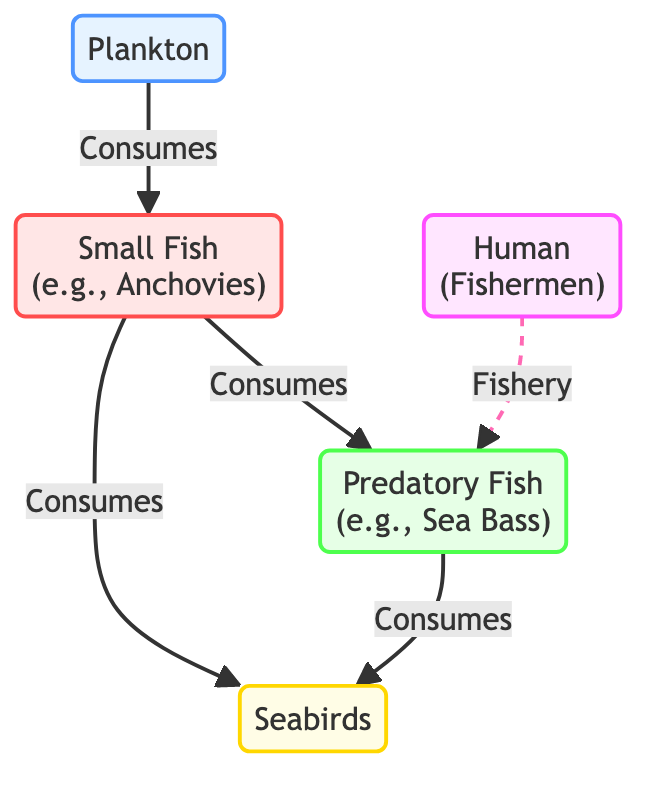What are the nodes in the diagram? The diagram includes the following nodes: Plankton, Small Fish, Predatory Fish, Human, and Seabirds.
Answer: Plankton, Small Fish, Predatory Fish, Human, Seabirds What type of fish is directly consumed by small fish? The diagram indicates that small fish consume plankton.
Answer: Plankton How many primary consumers are present in the diagram? There are two primary consumers visible in the diagram: small fish and seabirds.
Answer: 2 Who are the human participants in the food chain? The diagram shows humans represented as fishermen in the food chain.
Answer: Fishermen Which fish consumes seabirds according to the diagram? The diagram indicates that predatory fish consume seabirds.
Answer: Predatory Fish What is the relationship between plankton and small fish? Small fish consume plankton according to the flow represented in the diagram.
Answer: Consumes How many paths lead away from the small fish node? The small fish node has three paths leading away: to predatory fish and to seabirds (with one being implied through consumption).
Answer: 3 What type of arrow represents the fishery relationship between humans and predatory fish? The human node has a dashed arrow indicating a fishery relationship with predatory fish in the diagram.
Answer: Dashed arrow Which node has a direct association with small fish consumption? The small fish node has a direct relationship with both plankton and seabirds since it consumes both.
Answer: Plankton, Seabirds 